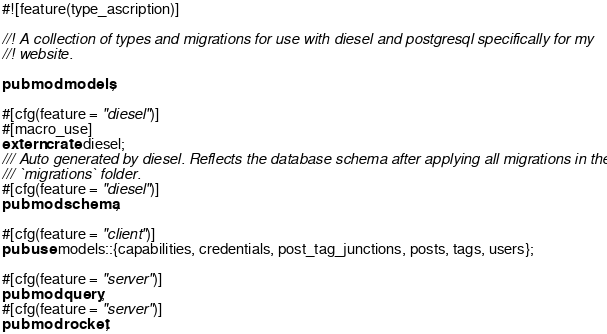Convert code to text. <code><loc_0><loc_0><loc_500><loc_500><_Rust_>#![feature(type_ascription)]

//! A collection of types and migrations for use with diesel and postgresql specifically for my
//! website.

pub mod models;

#[cfg(feature = "diesel")]
#[macro_use]
extern crate diesel;
/// Auto generated by diesel. Reflects the database schema after applying all migrations in the
/// `migrations` folder.
#[cfg(feature = "diesel")]
pub mod schema;

#[cfg(feature = "client")]
pub use models::{capabilities, credentials, post_tag_junctions, posts, tags, users};

#[cfg(feature = "server")]
pub mod query;
#[cfg(feature = "server")]
pub mod rocket;
</code> 